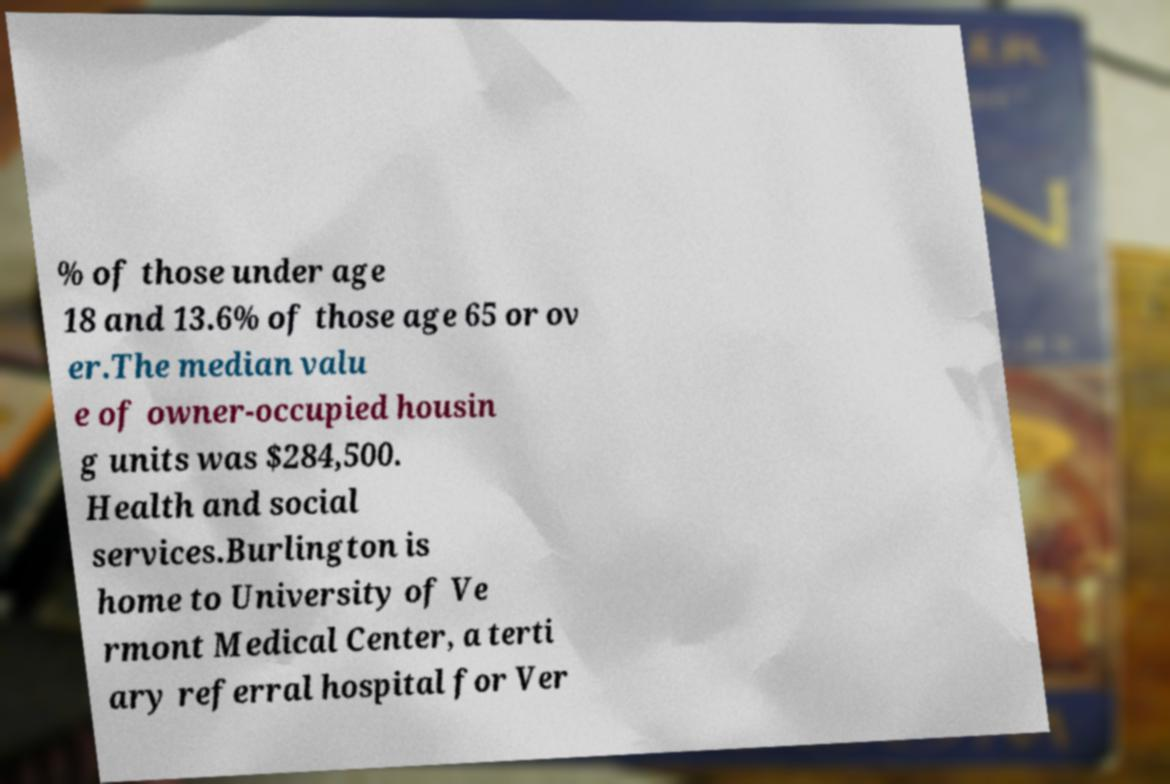Could you extract and type out the text from this image? % of those under age 18 and 13.6% of those age 65 or ov er.The median valu e of owner-occupied housin g units was $284,500. Health and social services.Burlington is home to University of Ve rmont Medical Center, a terti ary referral hospital for Ver 